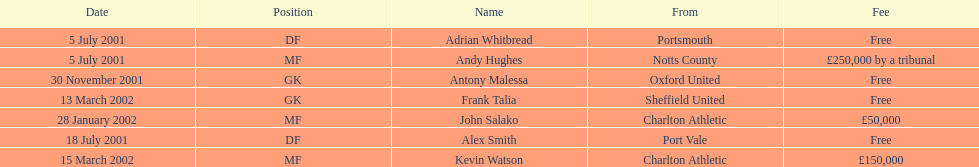What was the relocation cost for moving kevin watson? £150,000. 